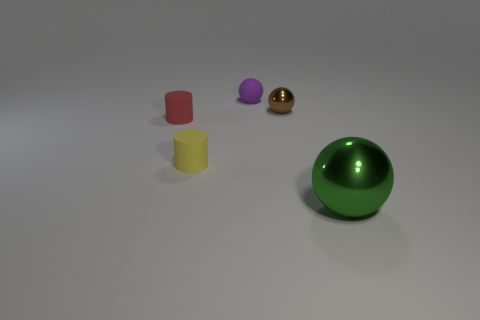What color is the small ball that is made of the same material as the yellow cylinder?
Offer a very short reply. Purple. There is a thing that is right of the small purple sphere and behind the big green sphere; how big is it?
Offer a very short reply. Small. Are there fewer tiny red matte objects behind the brown ball than objects behind the tiny purple rubber sphere?
Your response must be concise. No. Are the small sphere that is right of the tiny purple object and the tiny cylinder behind the tiny yellow cylinder made of the same material?
Ensure brevity in your answer.  No. There is a tiny rubber thing that is behind the tiny yellow object and to the left of the tiny purple matte sphere; what shape is it?
Provide a short and direct response. Cylinder. The tiny sphere that is in front of the small sphere left of the brown thing is made of what material?
Provide a succinct answer. Metal. Are there more green spheres than metal objects?
Provide a succinct answer. No. Is the tiny rubber ball the same color as the big metal thing?
Your response must be concise. No. There is a yellow cylinder that is the same size as the purple rubber sphere; what is its material?
Provide a short and direct response. Rubber. Are the tiny brown sphere and the green thing made of the same material?
Give a very brief answer. Yes. 